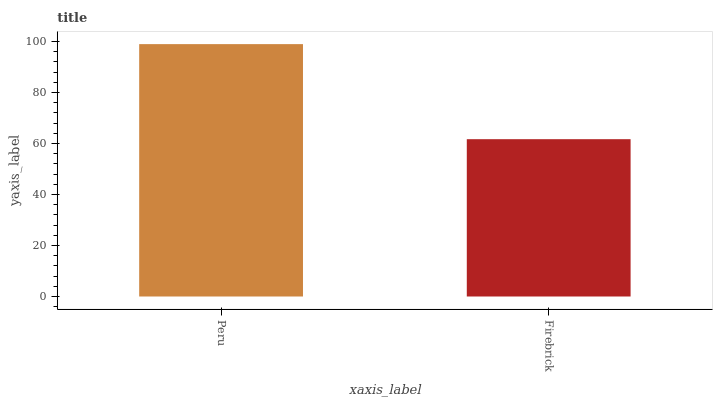Is Firebrick the maximum?
Answer yes or no. No. Is Peru greater than Firebrick?
Answer yes or no. Yes. Is Firebrick less than Peru?
Answer yes or no. Yes. Is Firebrick greater than Peru?
Answer yes or no. No. Is Peru less than Firebrick?
Answer yes or no. No. Is Peru the high median?
Answer yes or no. Yes. Is Firebrick the low median?
Answer yes or no. Yes. Is Firebrick the high median?
Answer yes or no. No. Is Peru the low median?
Answer yes or no. No. 